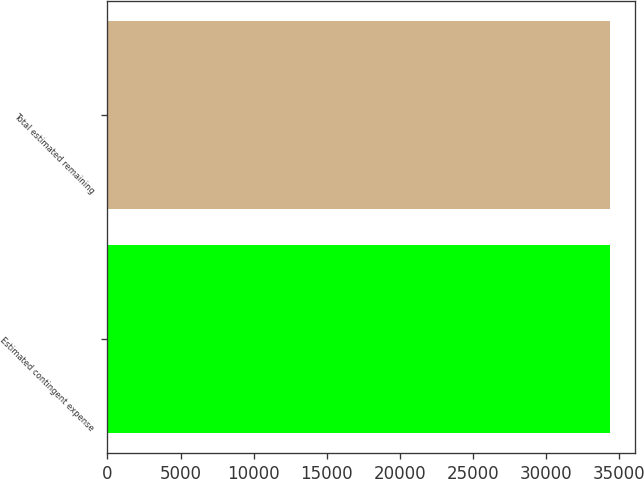Convert chart. <chart><loc_0><loc_0><loc_500><loc_500><bar_chart><fcel>Estimated contingent expense<fcel>Total estimated remaining<nl><fcel>34342<fcel>34342.1<nl></chart> 